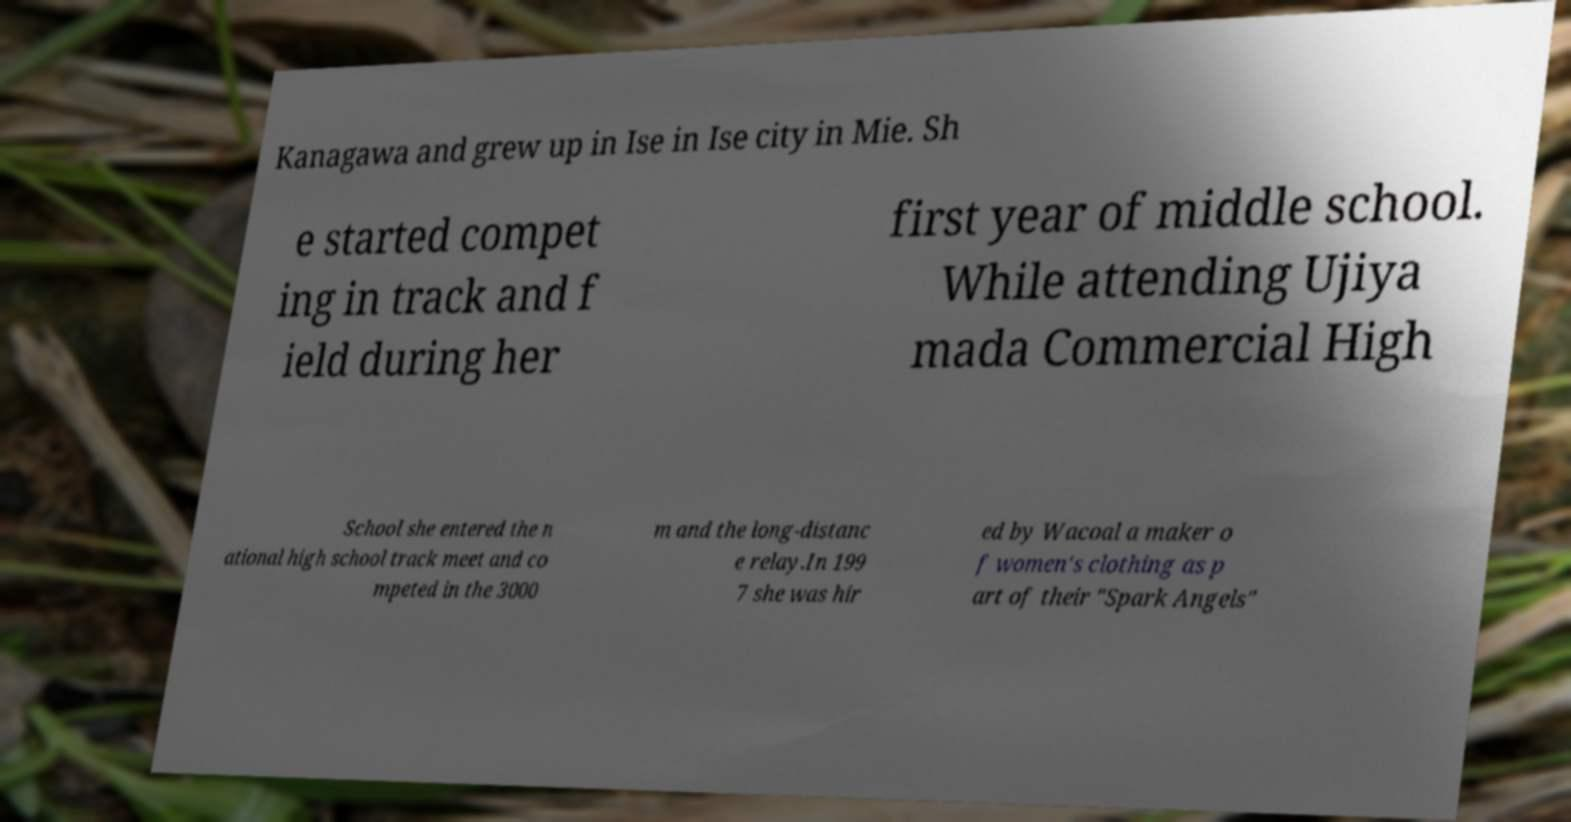There's text embedded in this image that I need extracted. Can you transcribe it verbatim? Kanagawa and grew up in Ise in Ise city in Mie. Sh e started compet ing in track and f ield during her first year of middle school. While attending Ujiya mada Commercial High School she entered the n ational high school track meet and co mpeted in the 3000 m and the long-distanc e relay.In 199 7 she was hir ed by Wacoal a maker o f women's clothing as p art of their "Spark Angels" 